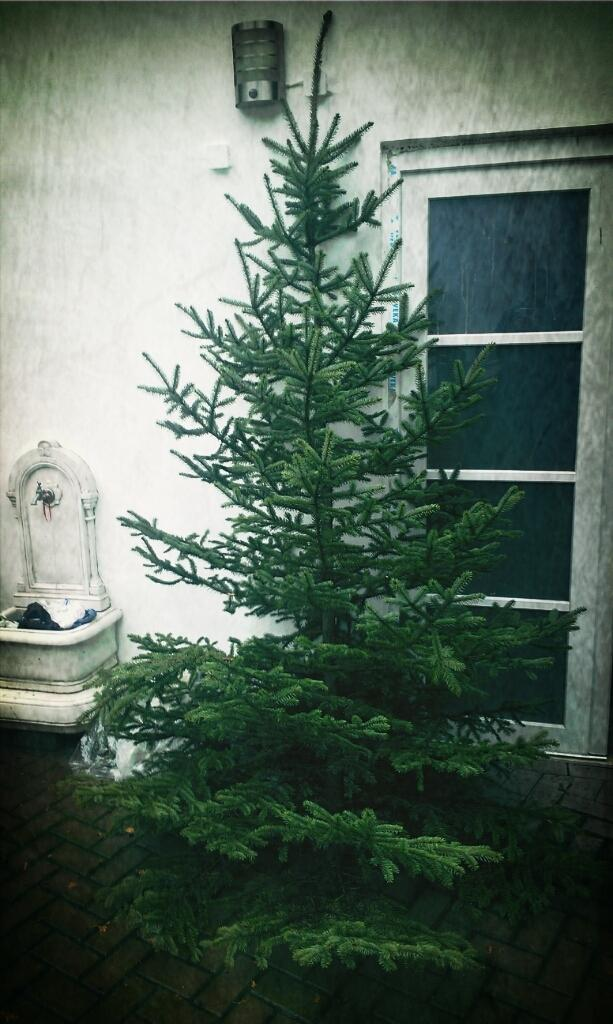What is the main subject in the middle of the image? There is a plant in the middle of the image. What can be seen on the right side of the image? There is a window on the right side of the image. What type of agreement is being signed by the tooth in the image? There is no tooth present in the image, and therefore no agreement can be signed. 